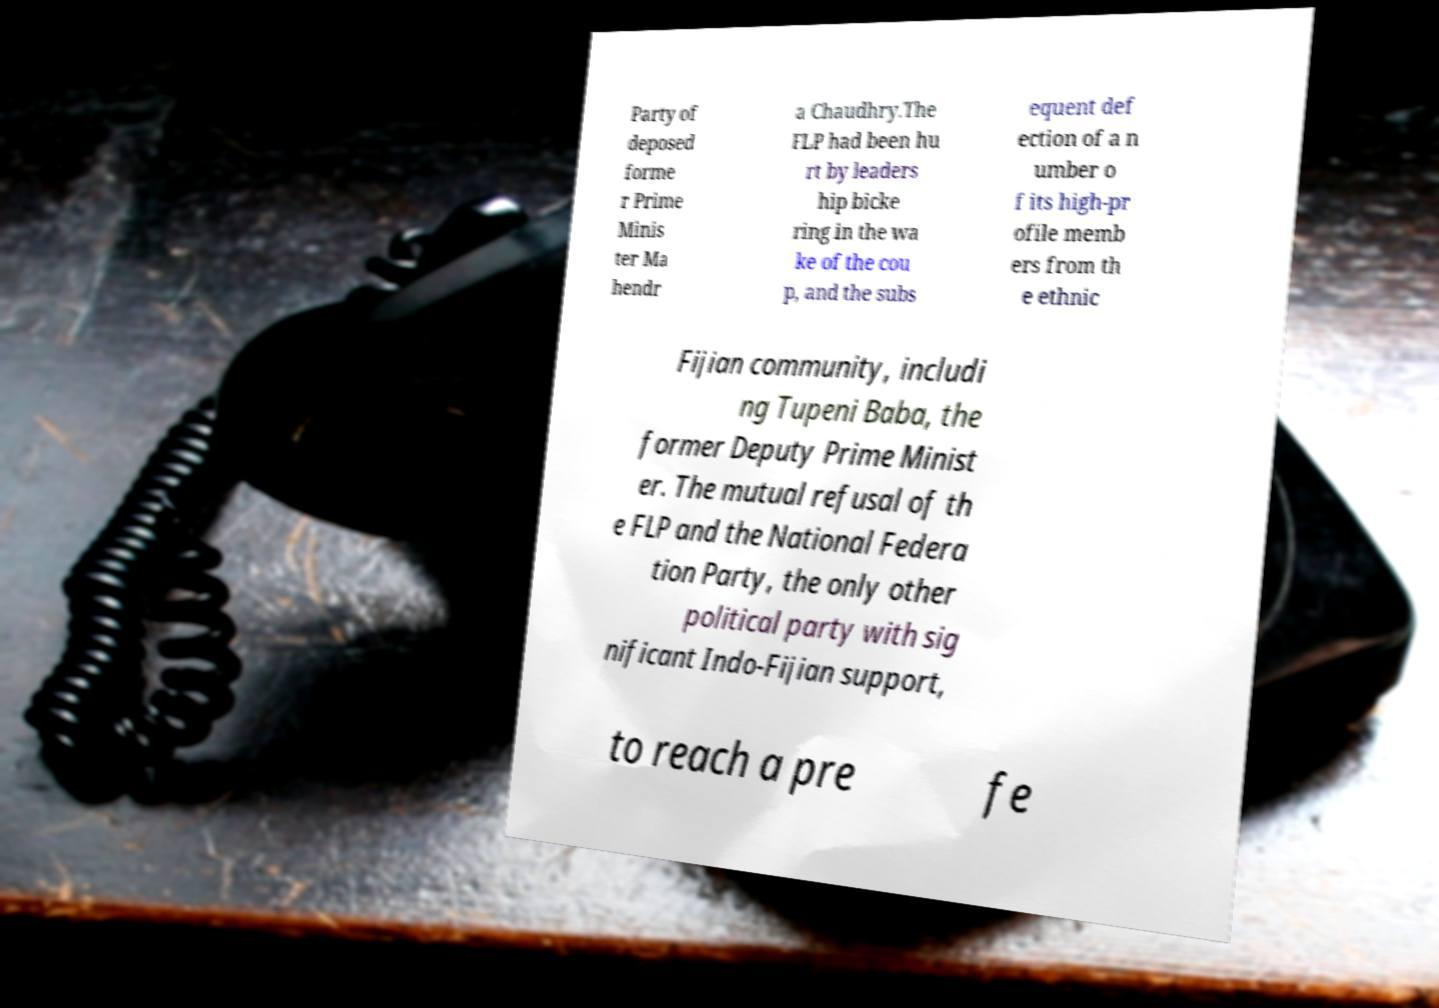Could you assist in decoding the text presented in this image and type it out clearly? Party of deposed forme r Prime Minis ter Ma hendr a Chaudhry.The FLP had been hu rt by leaders hip bicke ring in the wa ke of the cou p, and the subs equent def ection of a n umber o f its high-pr ofile memb ers from th e ethnic Fijian community, includi ng Tupeni Baba, the former Deputy Prime Minist er. The mutual refusal of th e FLP and the National Federa tion Party, the only other political party with sig nificant Indo-Fijian support, to reach a pre fe 